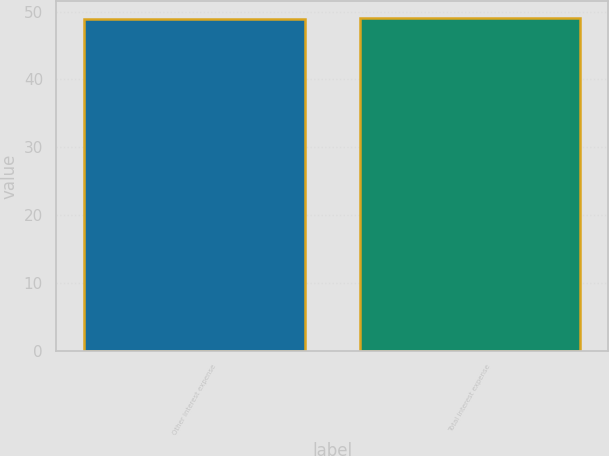Convert chart. <chart><loc_0><loc_0><loc_500><loc_500><bar_chart><fcel>Other interest expense<fcel>Total interest expense<nl><fcel>49<fcel>49.1<nl></chart> 